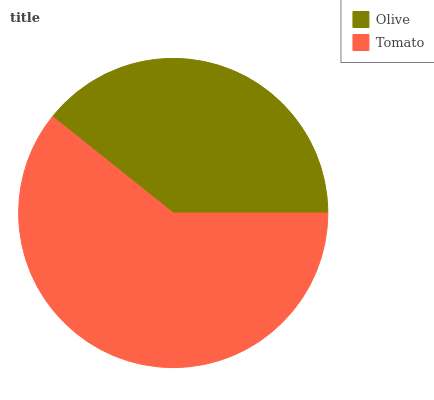Is Olive the minimum?
Answer yes or no. Yes. Is Tomato the maximum?
Answer yes or no. Yes. Is Tomato the minimum?
Answer yes or no. No. Is Tomato greater than Olive?
Answer yes or no. Yes. Is Olive less than Tomato?
Answer yes or no. Yes. Is Olive greater than Tomato?
Answer yes or no. No. Is Tomato less than Olive?
Answer yes or no. No. Is Tomato the high median?
Answer yes or no. Yes. Is Olive the low median?
Answer yes or no. Yes. Is Olive the high median?
Answer yes or no. No. Is Tomato the low median?
Answer yes or no. No. 